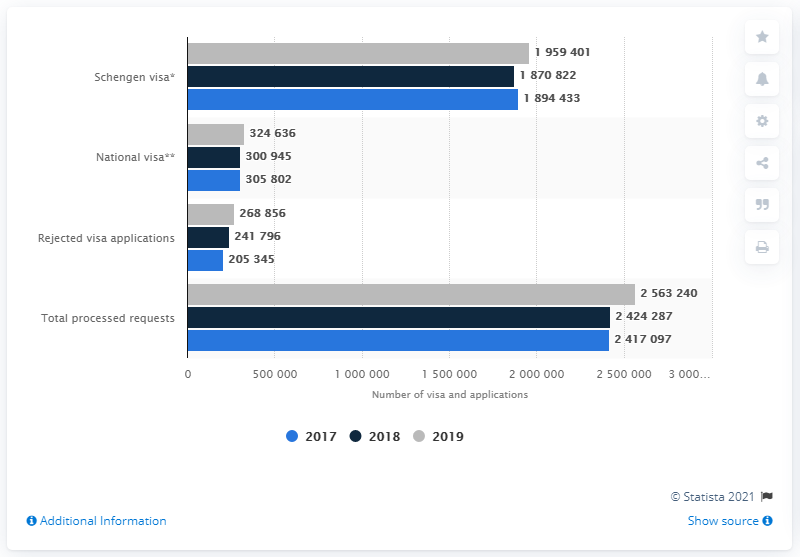List a handful of essential elements in this visual. In 2019, a total of 256,3240 visa requests were processed for a trip to Germany. In 2019, a total of 195,9401 visas were issued under the Schengen Agreement. 